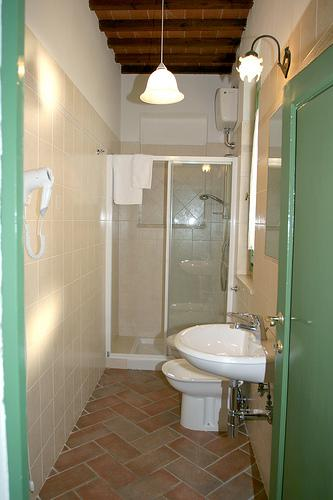Question: what is the shower doors made of?
Choices:
A. Glass.
B. Wood.
C. Plastic.
D. Stainless steel.
Answer with the letter. Answer: A Question: where is the mirror?
Choices:
A. Above the dresser.
B. Over the desk.
C. Over the couch.
D. Above the sink.
Answer with the letter. Answer: D Question: how many lights are in the room?
Choices:
A. 2.
B. 3.
C. 4.
D. 5.
Answer with the letter. Answer: A 